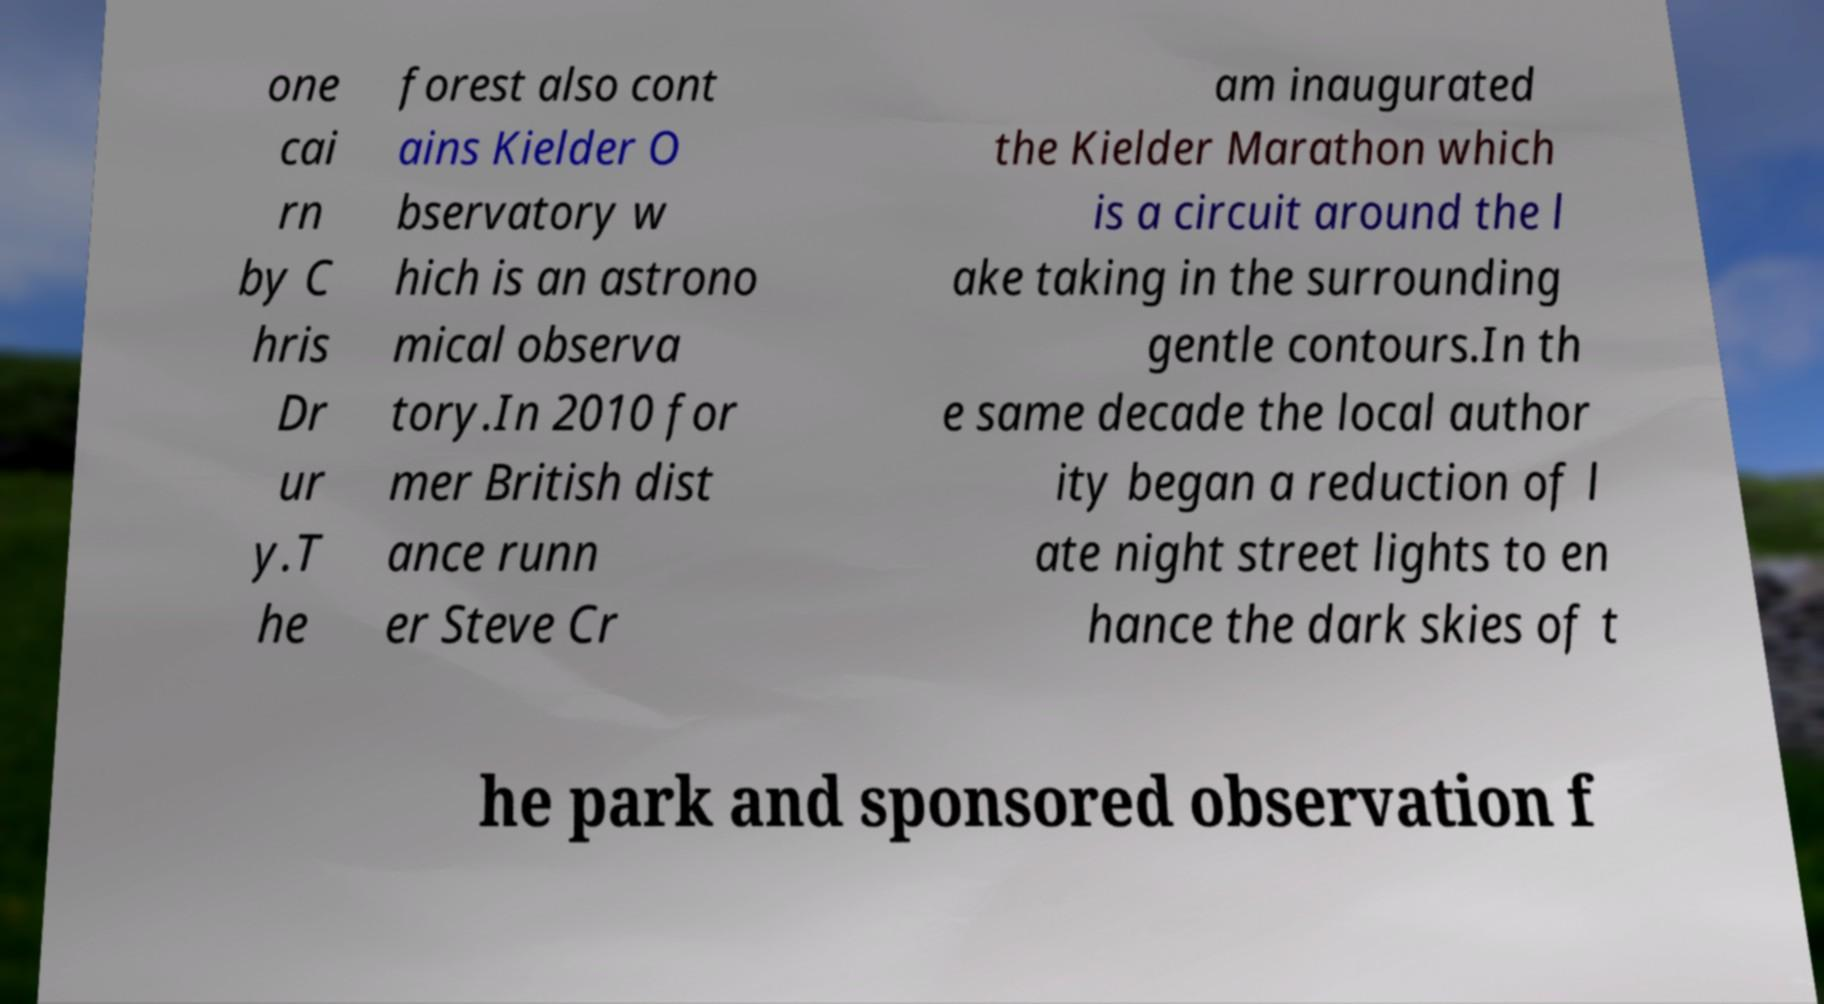Could you extract and type out the text from this image? one cai rn by C hris Dr ur y.T he forest also cont ains Kielder O bservatory w hich is an astrono mical observa tory.In 2010 for mer British dist ance runn er Steve Cr am inaugurated the Kielder Marathon which is a circuit around the l ake taking in the surrounding gentle contours.In th e same decade the local author ity began a reduction of l ate night street lights to en hance the dark skies of t he park and sponsored observation f 